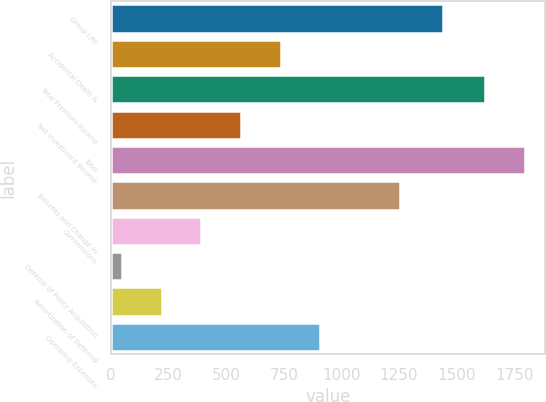<chart> <loc_0><loc_0><loc_500><loc_500><bar_chart><fcel>Group Life<fcel>Accidental Death &<fcel>Total Premium Income<fcel>Net Investment Income<fcel>Total<fcel>Benefits and Change in<fcel>Commissions<fcel>Deferral of Policy Acquisition<fcel>Amortization of Deferred<fcel>Operating Expenses<nl><fcel>1441<fcel>736.48<fcel>1623.4<fcel>564.11<fcel>1795.77<fcel>1253.59<fcel>391.74<fcel>47<fcel>219.37<fcel>908.85<nl></chart> 